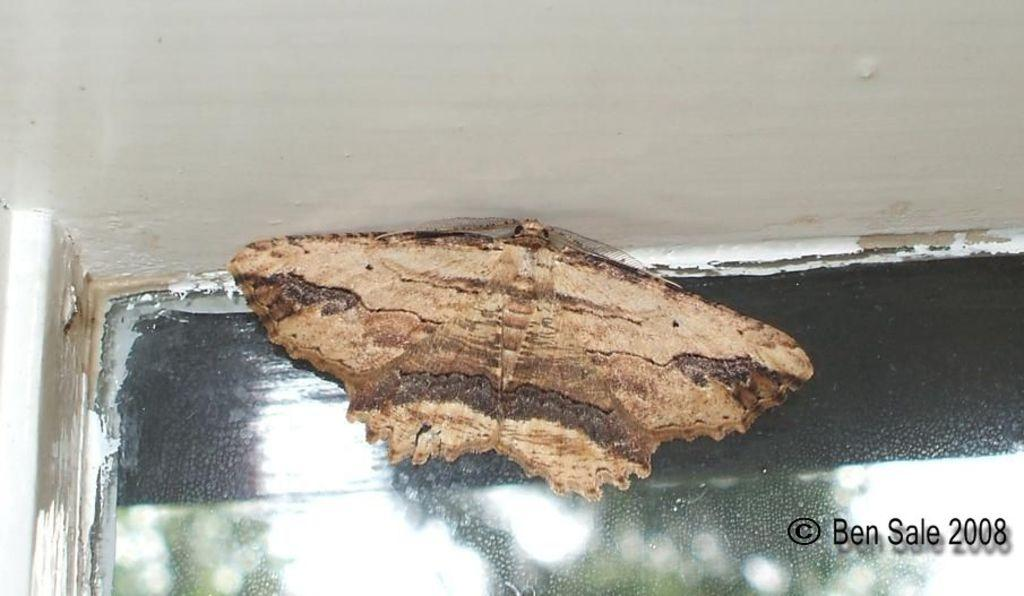What is present on the wall in the image? There is an insect on the wall in the image. What additional feature can be observed in the image? There is a watermark in the image. What type of house is visible on the island in the image? There is no house or island present in the image; it only features an insect on the wall and a watermark. What activity is the insect engaged in on the wall in the image? The facts provided do not specify any activity the insect is engaged in; it is simply present on the wall. 